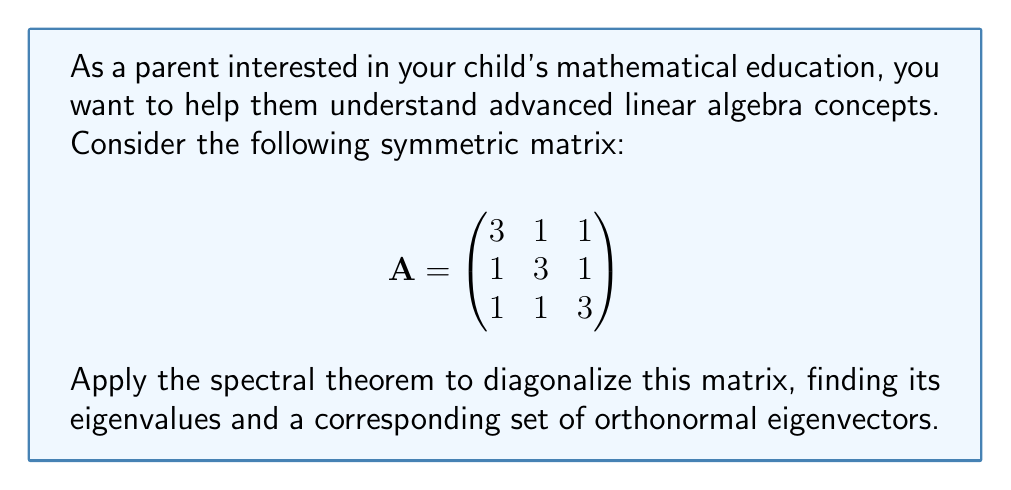Can you solve this math problem? Let's apply the spectral theorem step-by-step:

1) First, we need to find the eigenvalues of A. The characteristic equation is:
   $$det(A - \lambda I) = \begin{vmatrix}
   3-\lambda & 1 & 1 \\
   1 & 3-\lambda & 1 \\
   1 & 1 & 3-\lambda
   \end{vmatrix} = 0$$

2) Expanding this determinant:
   $(3-\lambda)^3 + 2 - 3(3-\lambda) = 0$
   $(3-\lambda)^3 - 9(3-\lambda) + 2 = 0$
   $(\lambda-5)(\lambda-2)^2 = 0$

3) So, the eigenvalues are $\lambda_1 = 5$ and $\lambda_2 = 2$ (with algebraic multiplicity 2).

4) Now, let's find the eigenvectors:

   For $\lambda_1 = 5$:
   $(A - 5I)\mathbf{v} = \mathbf{0}$
   Solving this, we get $\mathbf{v}_1 = \frac{1}{\sqrt{3}}(1, 1, 1)^T$

   For $\lambda_2 = 2$:
   $(A - 2I)\mathbf{v} = \mathbf{0}$
   Solving this, we get two orthogonal eigenvectors:
   $\mathbf{v}_2 = \frac{1}{\sqrt{2}}(-1, 0, 1)^T$ and $\mathbf{v}_3 = \frac{1}{\sqrt{6}}(-1, 2, -1)^T$

5) These eigenvectors form an orthonormal basis. We can construct the orthogonal matrix P:
   $$P = \begin{pmatrix}
   \frac{1}{\sqrt{3}} & -\frac{1}{\sqrt{2}} & -\frac{1}{\sqrt{6}} \\
   \frac{1}{\sqrt{3}} & 0 & \frac{2}{\sqrt{6}} \\
   \frac{1}{\sqrt{3}} & \frac{1}{\sqrt{2}} & -\frac{1}{\sqrt{6}}
   \end{pmatrix}$$

6) The diagonalization is then:
   $$A = PDP^T$$
   where D is the diagonal matrix of eigenvalues:
   $$D = \begin{pmatrix}
   5 & 0 & 0 \\
   0 & 2 & 0 \\
   0 & 0 & 2
   \end{pmatrix}$$

This completes the diagonalization using the spectral theorem.
Answer: $\lambda_1 = 5, \lambda_2 = \lambda_3 = 2$; $\mathbf{v}_1 = \frac{1}{\sqrt{3}}(1, 1, 1)^T, \mathbf{v}_2 = \frac{1}{\sqrt{2}}(-1, 0, 1)^T, \mathbf{v}_3 = \frac{1}{\sqrt{6}}(-1, 2, -1)^T$ 